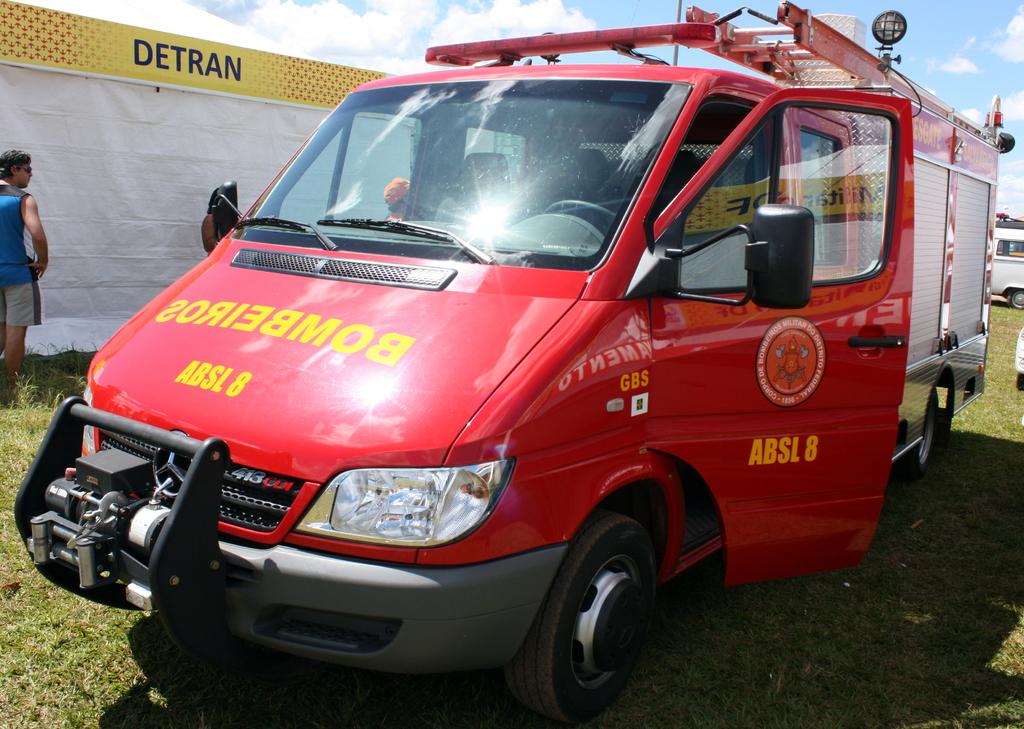What number is this vehicle?
Keep it short and to the point. 8. 